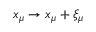Convert formula to latex. <formula><loc_0><loc_0><loc_500><loc_500>x _ { \mu } \to x _ { \mu } + \xi _ { \mu }</formula> 